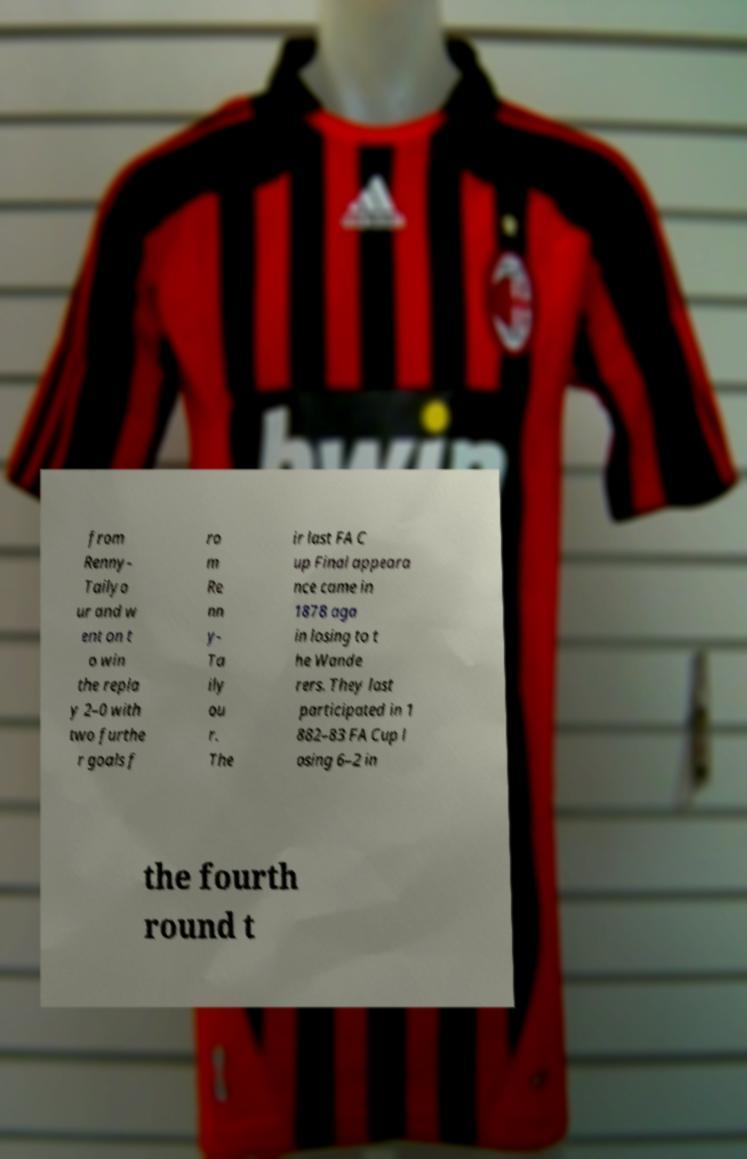Can you accurately transcribe the text from the provided image for me? from Renny- Tailyo ur and w ent on t o win the repla y 2–0 with two furthe r goals f ro m Re nn y- Ta ily ou r. The ir last FA C up Final appeara nce came in 1878 aga in losing to t he Wande rers. They last participated in 1 882–83 FA Cup l osing 6–2 in the fourth round t 